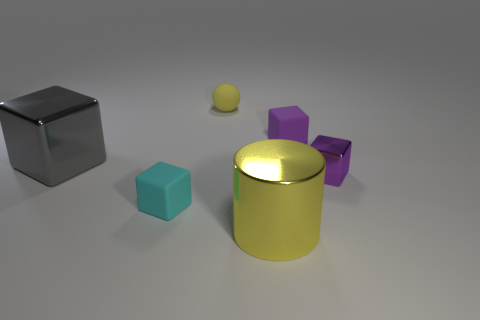What material is the small ball that is the same color as the shiny cylinder?
Provide a short and direct response. Rubber. What is the yellow object in front of the purple thing that is in front of the big object left of the cyan block made of?
Provide a short and direct response. Metal. Are there the same number of large things that are on the right side of the tiny yellow matte object and yellow shiny objects?
Your response must be concise. Yes. Are there any other things that are the same size as the gray thing?
Your answer should be very brief. Yes. What number of objects are blocks or metallic cylinders?
Provide a succinct answer. 5. What shape is the yellow thing that is made of the same material as the gray block?
Provide a succinct answer. Cylinder. There is a yellow object in front of the matte block that is on the left side of the large yellow shiny thing; what is its size?
Your response must be concise. Large. What number of large objects are matte objects or yellow shiny cylinders?
Your answer should be compact. 1. What number of other objects are the same color as the cylinder?
Provide a short and direct response. 1. There is a matte object to the right of the yellow rubber thing; does it have the same size as the metal cube that is left of the small cyan thing?
Your answer should be compact. No. 